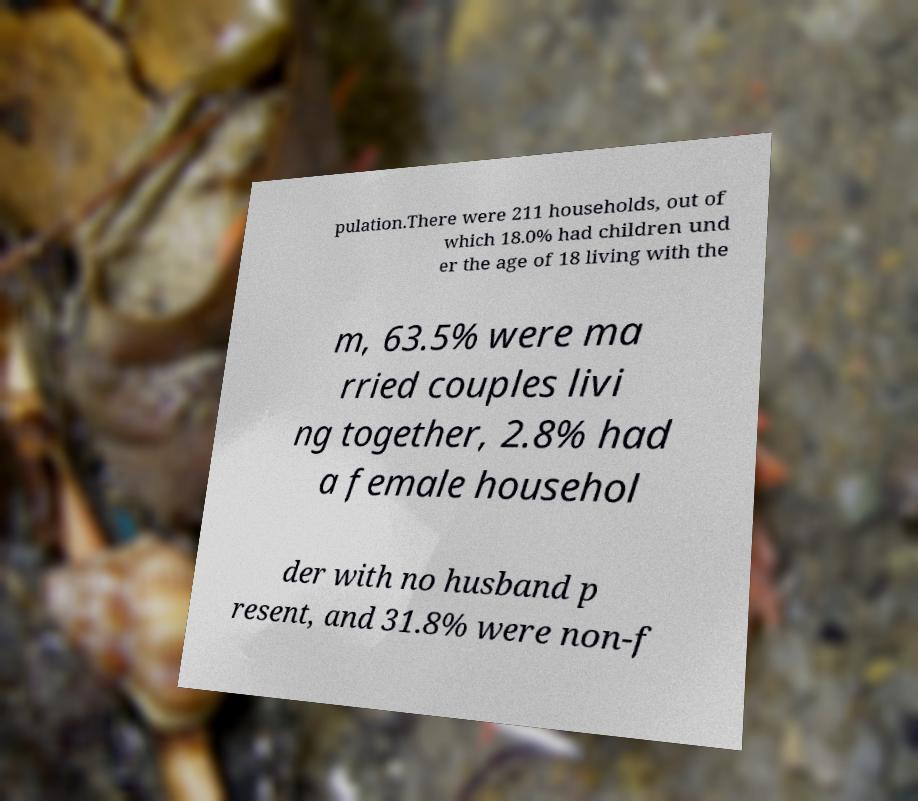There's text embedded in this image that I need extracted. Can you transcribe it verbatim? pulation.There were 211 households, out of which 18.0% had children und er the age of 18 living with the m, 63.5% were ma rried couples livi ng together, 2.8% had a female househol der with no husband p resent, and 31.8% were non-f 